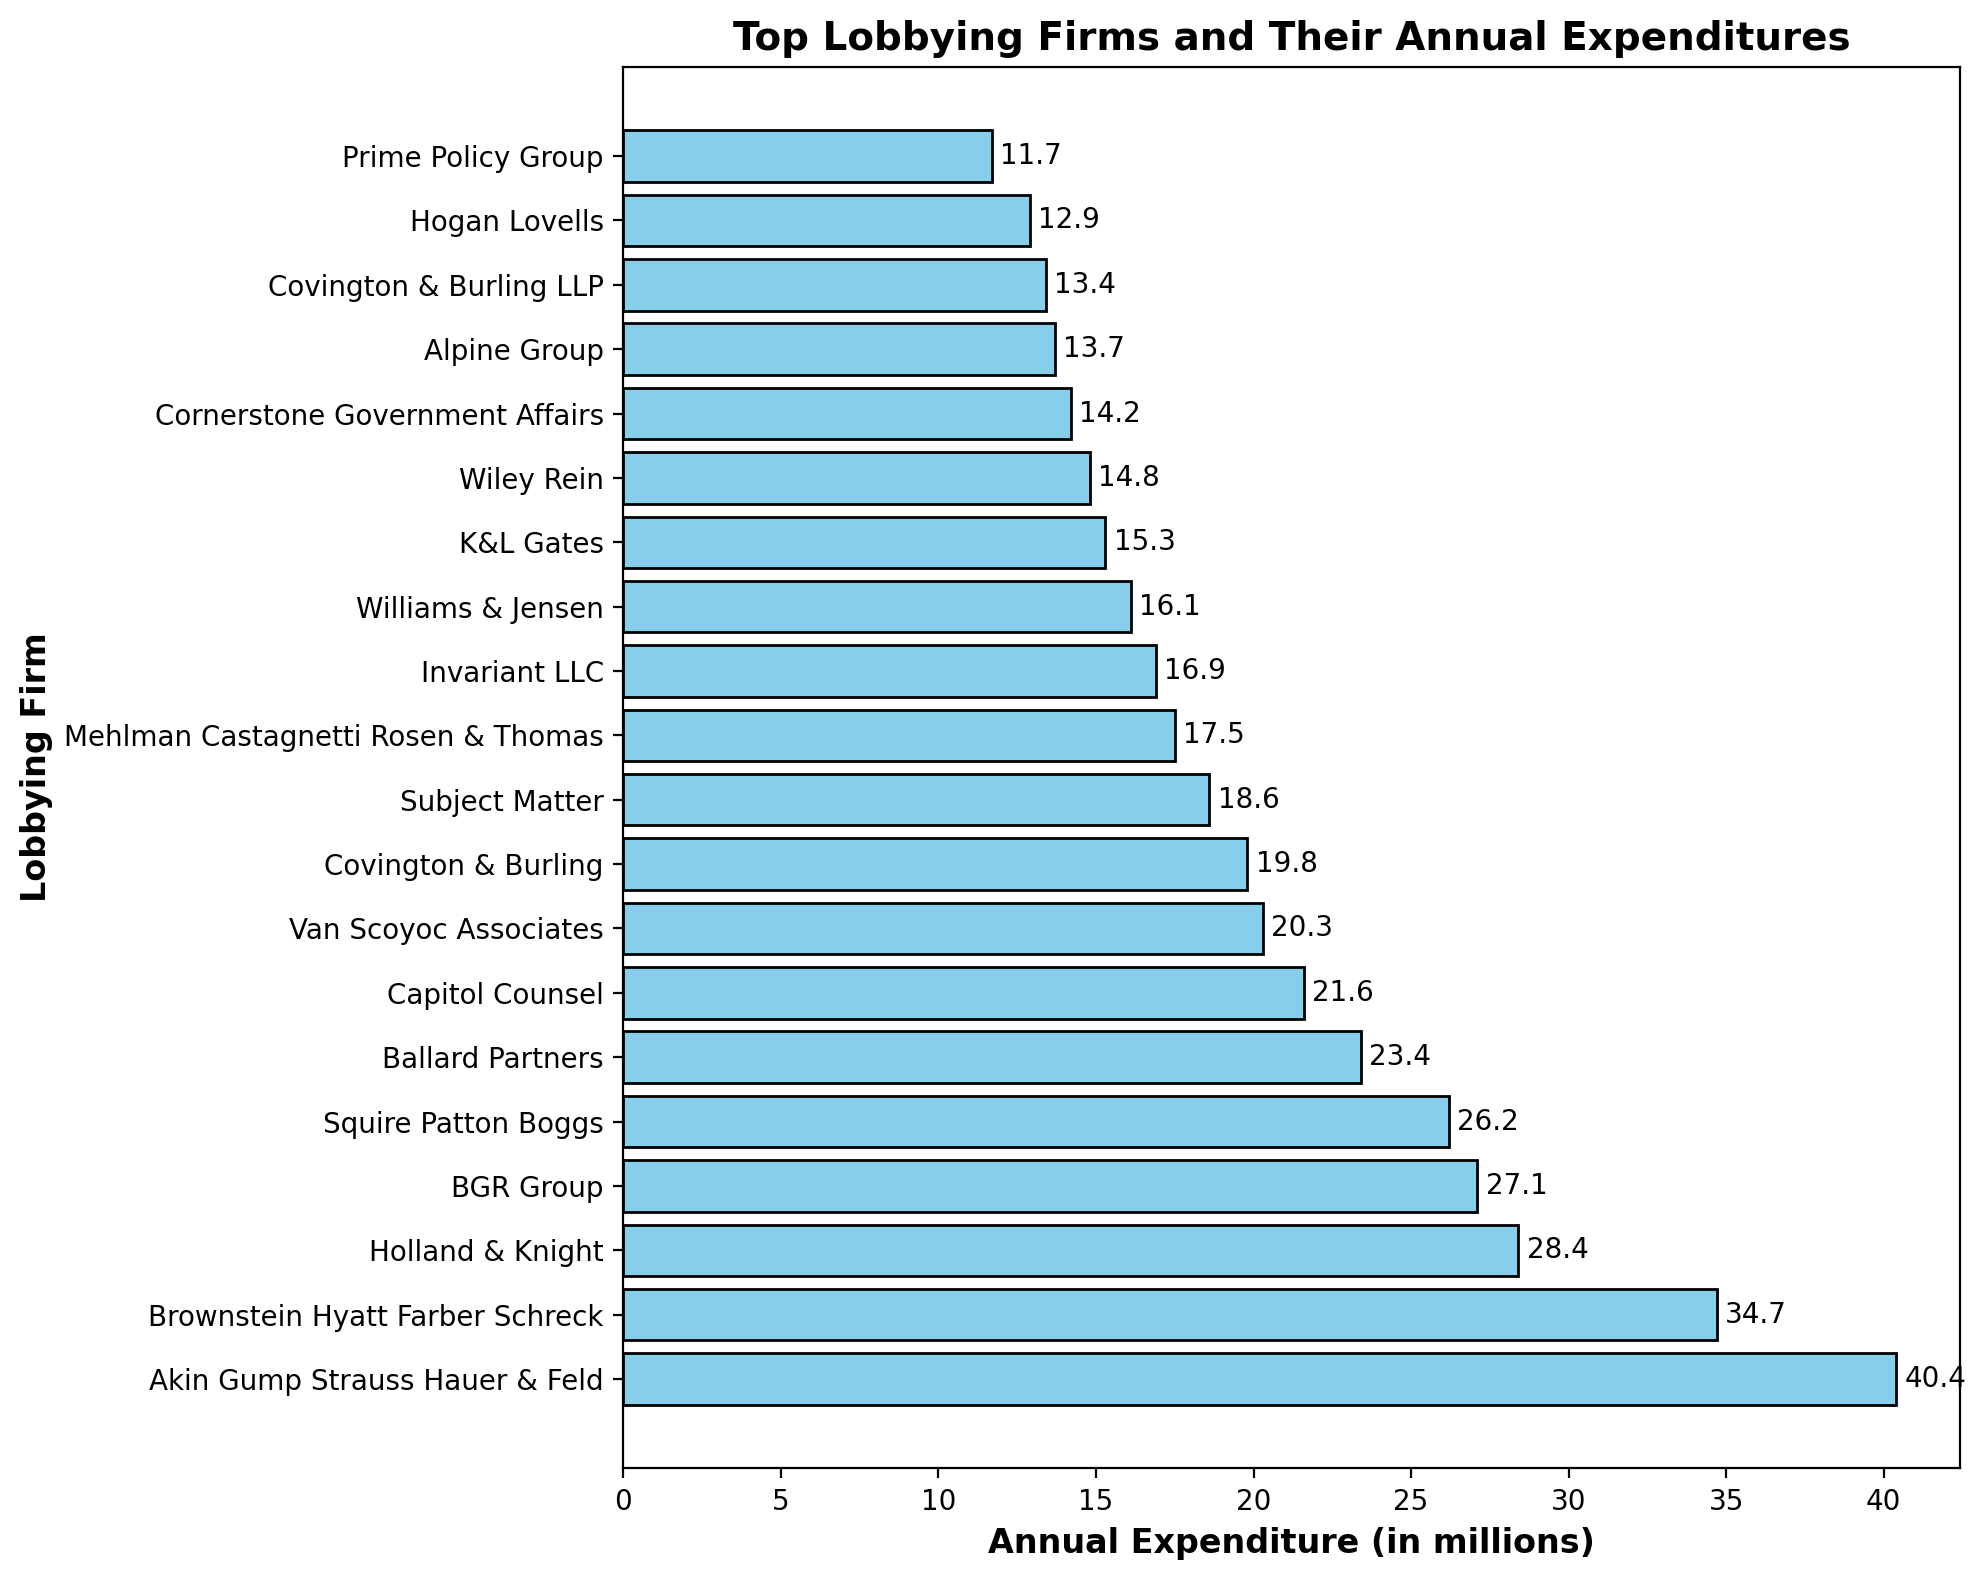Which lobbying firm has the highest annual expenditure? The topmost bar in the horizontal bar chart represents the lobbying firm with the highest annual expenditure. From the chart, the topmost is Akin Gump Strauss Hauer & Feld.
Answer: Akin Gump Strauss Hauer & Feld How much more does Brownstein Hyatt Farber Schreck spend annually compared to Wiley Rein? To find how much more Brownstein Hyatt Farber Schreck spends, locate their bars in the chart, find their expenditures, and subtract Wiley Rein's amount from Brownstein Hyatt Farber Schreck's. Brownstein Hyatt Farber Schreck spends $34.7 million, and Wiley Rein spends $14.8 million, performing the subtraction gives $34.7 million - $14.8 million = $19.9 million.
Answer: $19.9 million What are the combined annual expenditures of the top three lobbying firms? Sum the annual expenditures of the top three lobbying firms. The expenditures are $40.4 million (Akin Gump Strauss Hauer & Feld), $34.7 million (Brownstein Hyatt Farber Schreck), and $28.4 million (Holland & Knight). Adding them gives $40.4 million + $34.7 million + $28.4 million = $103.5 million.
Answer: $103.5 million Which lobbying firm ranks tenth in terms of annual expenditure, and what is that expenditure? By counting down ten bars from the top of the chart, the tenth firm is Subject Matter. The label adjacent to the bar shows that its annual expenditure is $18.6 million.
Answer: Subject Matter, $18.6 million What is the average annual expenditure of the bottom five firms? Sum the expenditures of the bottom five firms and divide by five. The amounts are $14.2 million, $13.7 million, $13.4 million, $12.9 million, and $11.7 million. The sum is $14.2 million + $13.7 million + $13.4 million + $12.9 million + $11.7 million = $65.9 million. The average is $65.9 million / 5 = $13.18 million.
Answer: $13.18 million Which lobbying firm spends less than $20 million but more than $18 million annually? Identify the firm(s) whose expenditure bars lie within the specified range. The chart shows Covington & Burling spends $19.8 million, which is within this range.
Answer: Covington & Burling How does the expenditure of Ballard Partners compare to that of Van Scoyoc Associates? Analyze the bars representing Ballard Partners and Van Scoyoc Associates. Ballard Partners spends $23.4 million, while Van Scoyoc Associates spends $20.3 million. Comparing these amounts, Ballard Partners spends more than Van Scoyoc Associates.
Answer: Ballard Partners spends more What is the total annual expenditure of all the lobbying firms listed in the chart? Sum all the expenditures given in the chart. The total expenditure is the sum of all individual expenditures which, when added up, yield $434.8 million.
Answer: $434.8 million 